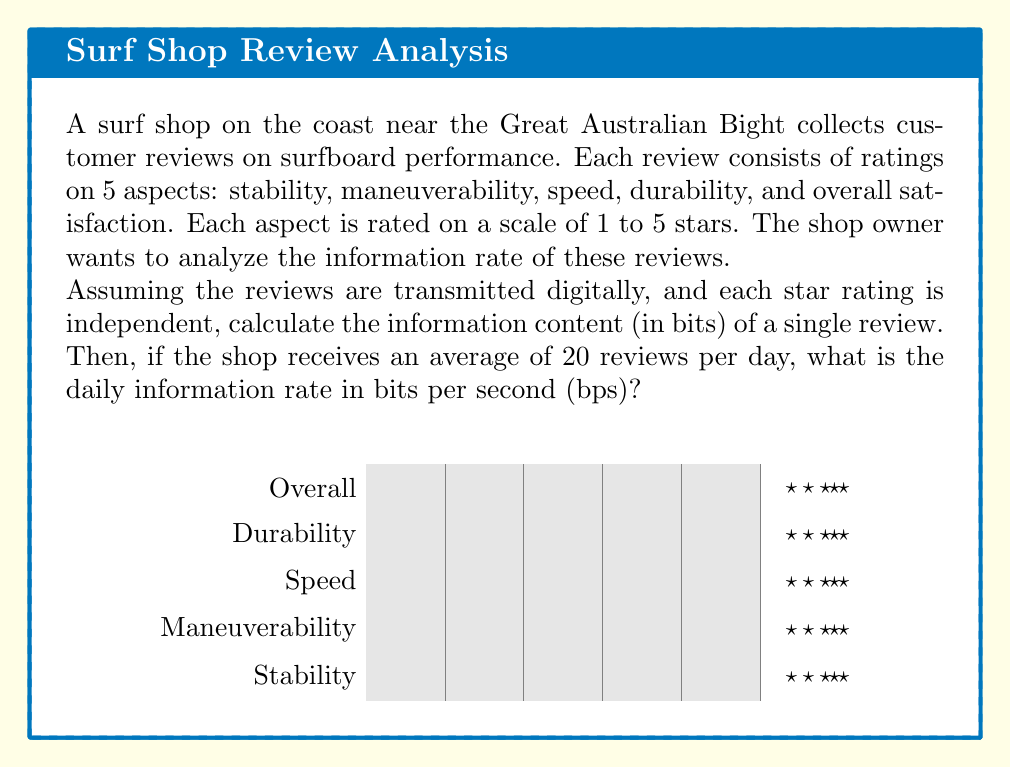Show me your answer to this math problem. Let's approach this step-by-step:

1) First, we need to calculate the information content of a single review.

2) Each aspect is rated on a scale of 1 to 5 stars, so there are 5 possible outcomes for each aspect.

3) The information content of a single aspect rating is:
   $$I = \log_2(5) \approx 2.32193 \text{ bits}$$

4) There are 5 aspects in total, and each is rated independently. So the total information content of a review is:
   $$I_{total} = 5 \times \log_2(5) \approx 5 \times 2.32193 = 11.60964 \text{ bits}$$

5) Now, let's calculate the daily information rate:
   - The shop receives an average of 20 reviews per day
   - Total daily information: $$20 \times 11.60964 = 232.19280 \text{ bits}$$

6) To convert this to bits per second (bps), we need to divide by the number of seconds in a day:
   $$\text{Rate} = \frac{232.19280 \text{ bits}}{24 \times 60 \times 60 \text{ seconds}} \approx 0.00268742 \text{ bps}$$

7) Rounding to 5 decimal places for practicality:
   $$\text{Rate} \approx 0.00269 \text{ bps}$$
Answer: 0.00269 bps 